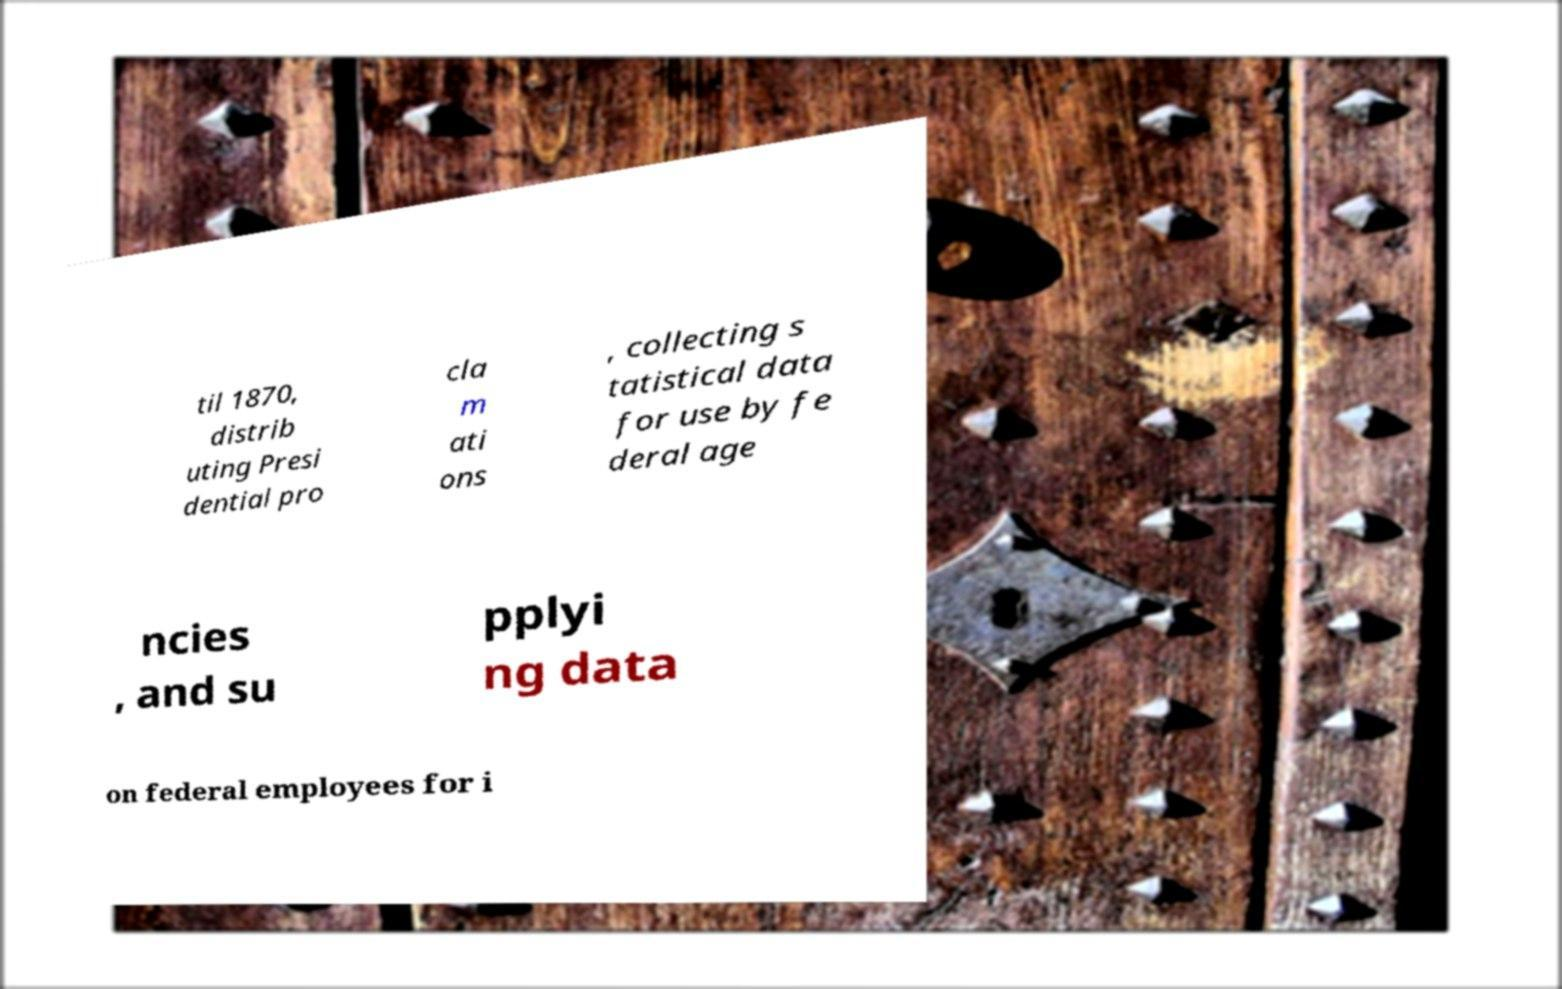What messages or text are displayed in this image? I need them in a readable, typed format. til 1870, distrib uting Presi dential pro cla m ati ons , collecting s tatistical data for use by fe deral age ncies , and su pplyi ng data on federal employees for i 